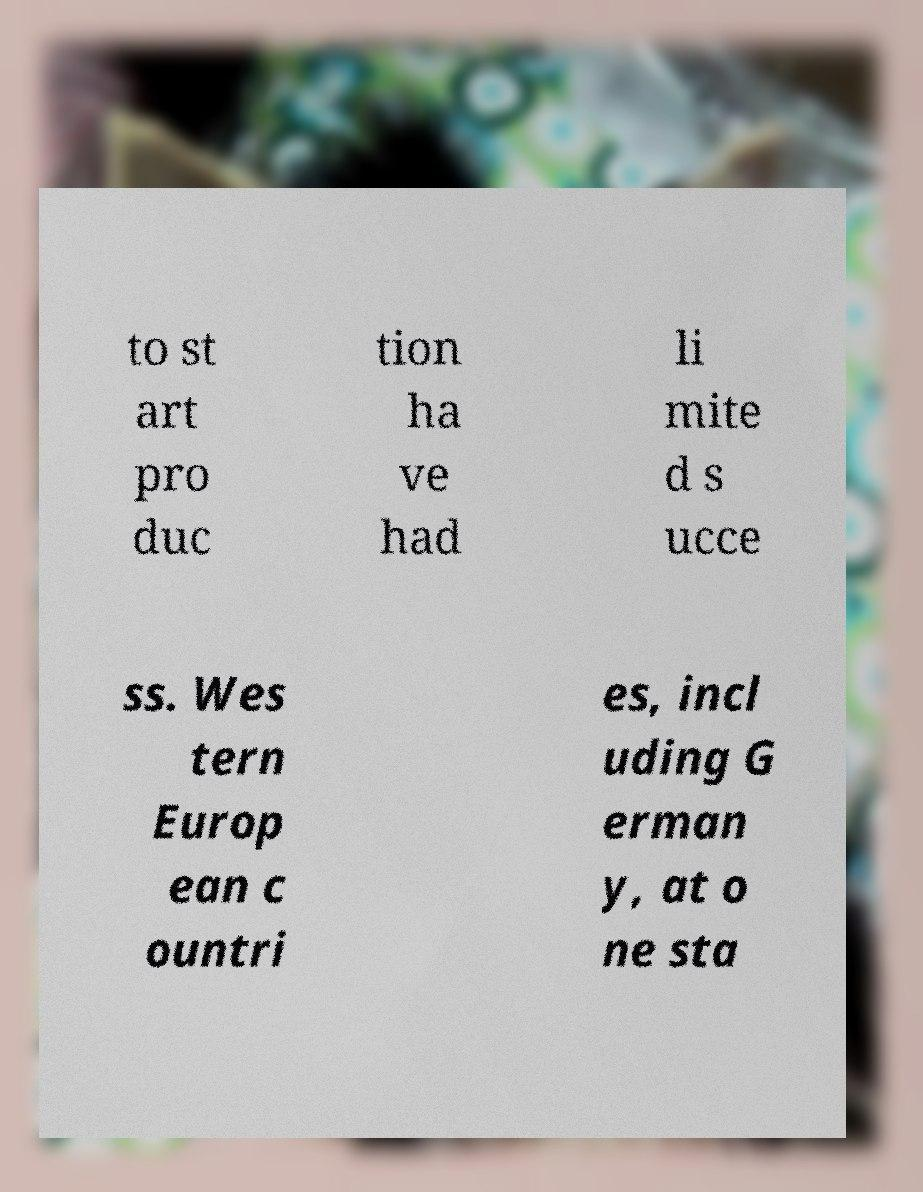Can you read and provide the text displayed in the image?This photo seems to have some interesting text. Can you extract and type it out for me? to st art pro duc tion ha ve had li mite d s ucce ss. Wes tern Europ ean c ountri es, incl uding G erman y, at o ne sta 